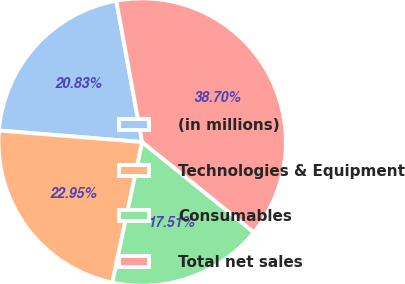Convert chart. <chart><loc_0><loc_0><loc_500><loc_500><pie_chart><fcel>(in millions)<fcel>Technologies & Equipment<fcel>Consumables<fcel>Total net sales<nl><fcel>20.83%<fcel>22.95%<fcel>17.51%<fcel>38.7%<nl></chart> 